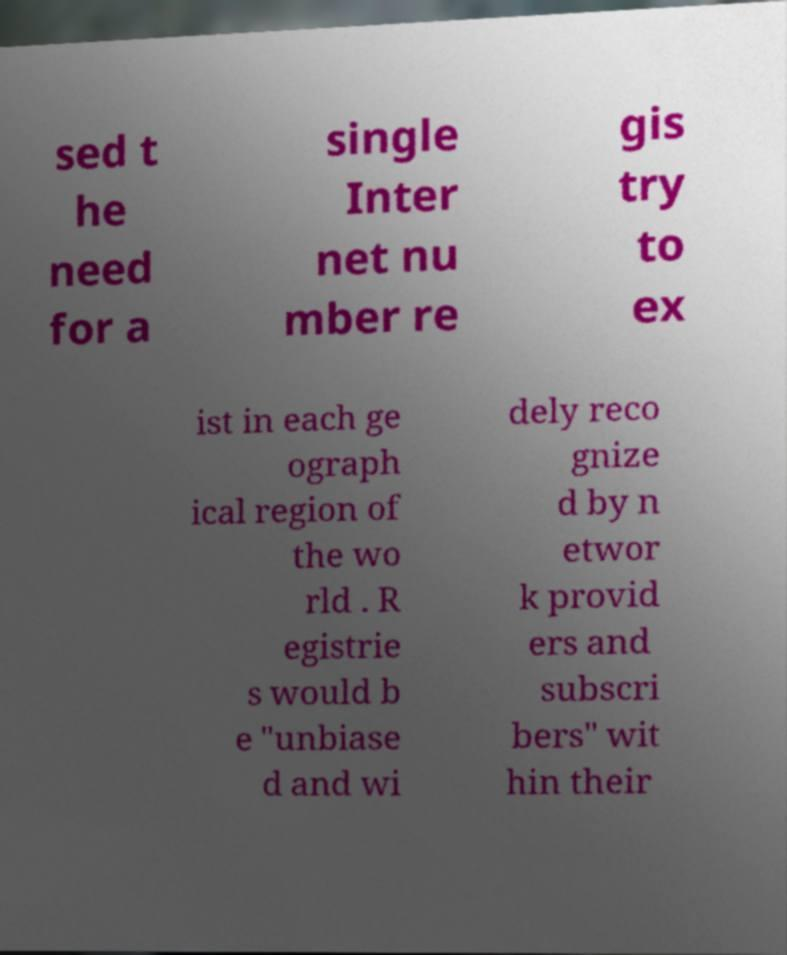Could you extract and type out the text from this image? sed t he need for a single Inter net nu mber re gis try to ex ist in each ge ograph ical region of the wo rld . R egistrie s would b e "unbiase d and wi dely reco gnize d by n etwor k provid ers and subscri bers" wit hin their 